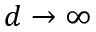<formula> <loc_0><loc_0><loc_500><loc_500>d \to \infty</formula> 